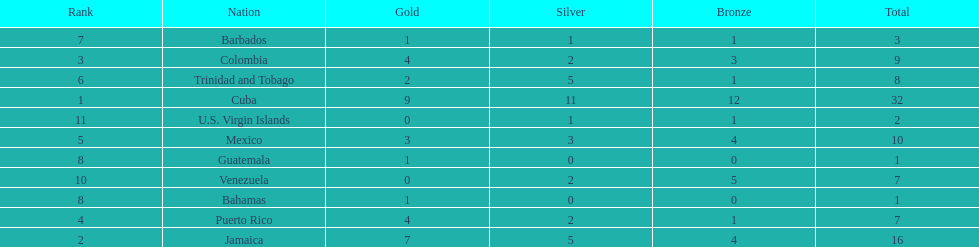What is the difference in medals between cuba and mexico? 22. 